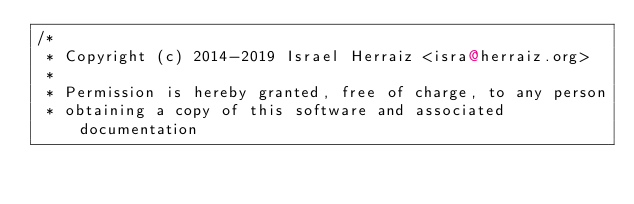Convert code to text. <code><loc_0><loc_0><loc_500><loc_500><_Scala_>/*
 * Copyright (c) 2014-2019 Israel Herraiz <isra@herraiz.org>
 *
 * Permission is hereby granted, free of charge, to any person
 * obtaining a copy of this software and associated documentation</code> 